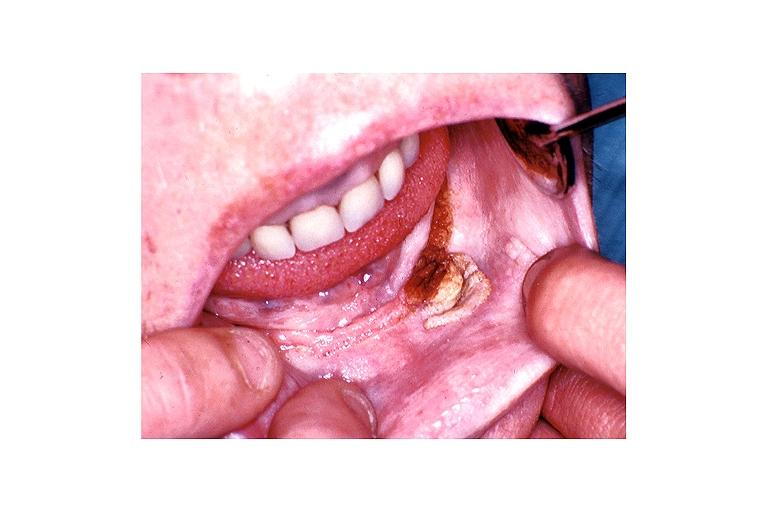does this image show verruca vulgaris?
Answer the question using a single word or phrase. Yes 